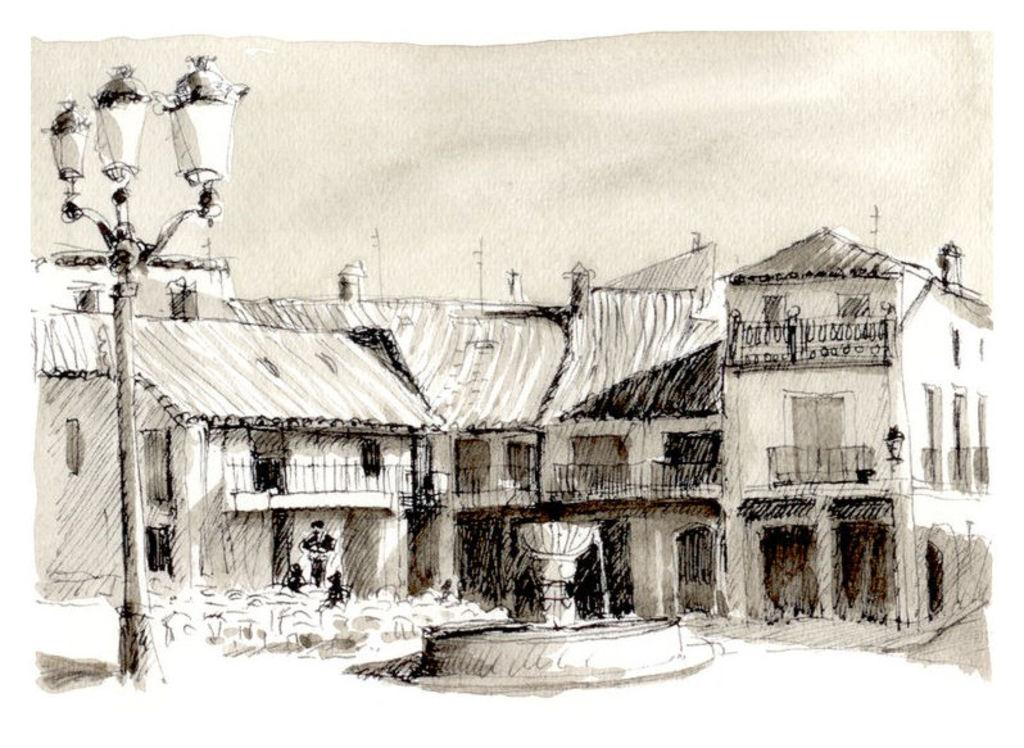What is the main subject of the image? The main subject of the image is an art of buildings. What can be seen in the middle of the image? There is a water fountain in the middle of the image. What is located on the left side of the image? There is a street light on the left side of the image. What is visible above the image? The sky is visible above the image. What type of plastic material is used to create the history in the image? There is no plastic or history depicted in the image; it features an art of buildings, a water fountain, a street light, and the sky. 